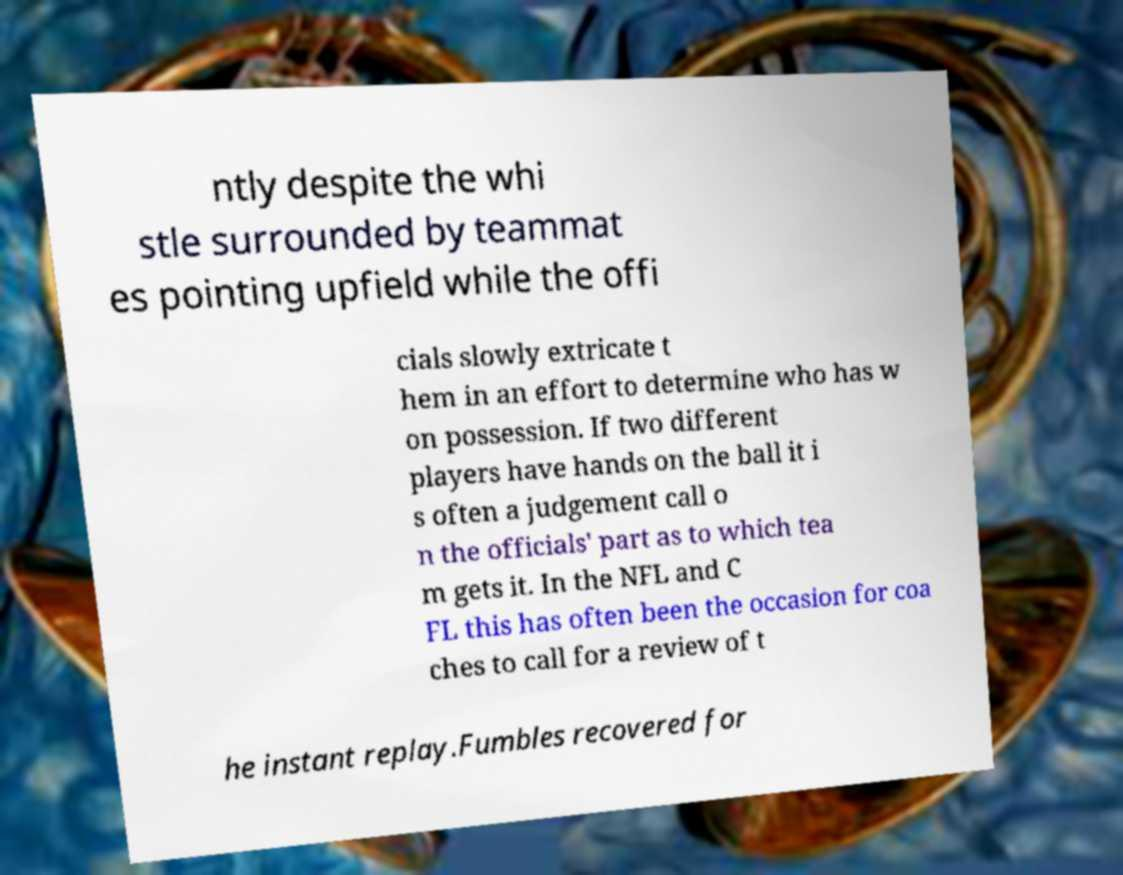Please identify and transcribe the text found in this image. ntly despite the whi stle surrounded by teammat es pointing upfield while the offi cials slowly extricate t hem in an effort to determine who has w on possession. If two different players have hands on the ball it i s often a judgement call o n the officials' part as to which tea m gets it. In the NFL and C FL this has often been the occasion for coa ches to call for a review of t he instant replay.Fumbles recovered for 